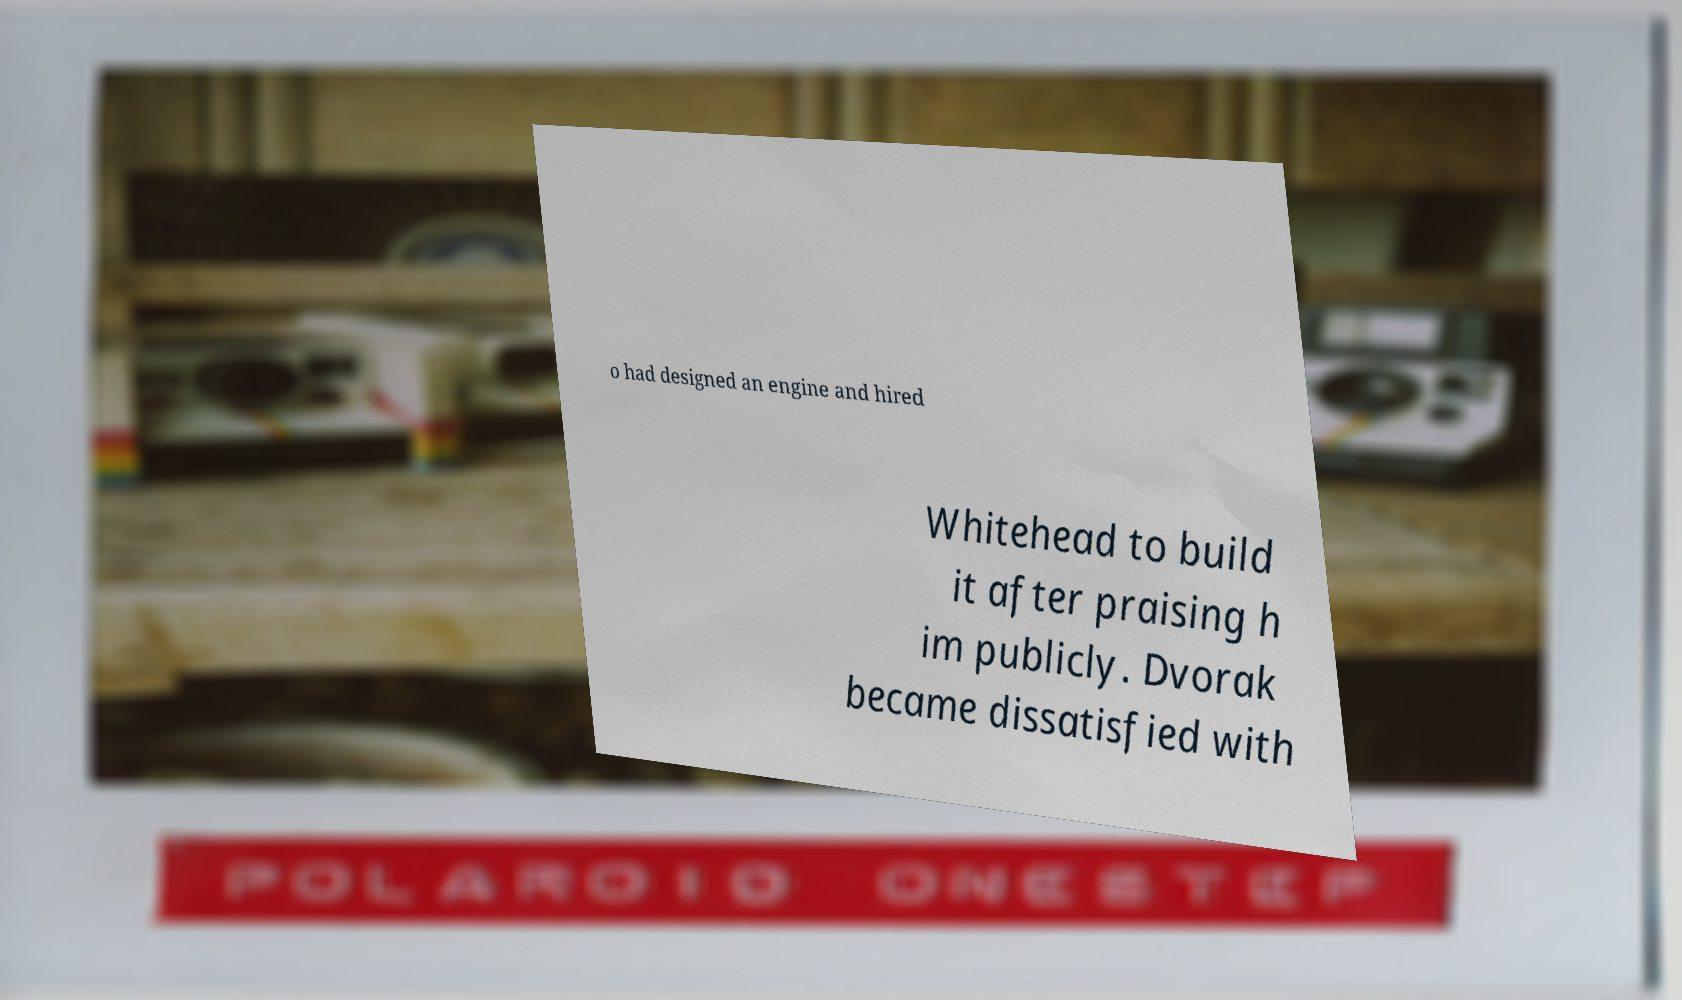What messages or text are displayed in this image? I need them in a readable, typed format. o had designed an engine and hired Whitehead to build it after praising h im publicly. Dvorak became dissatisfied with 